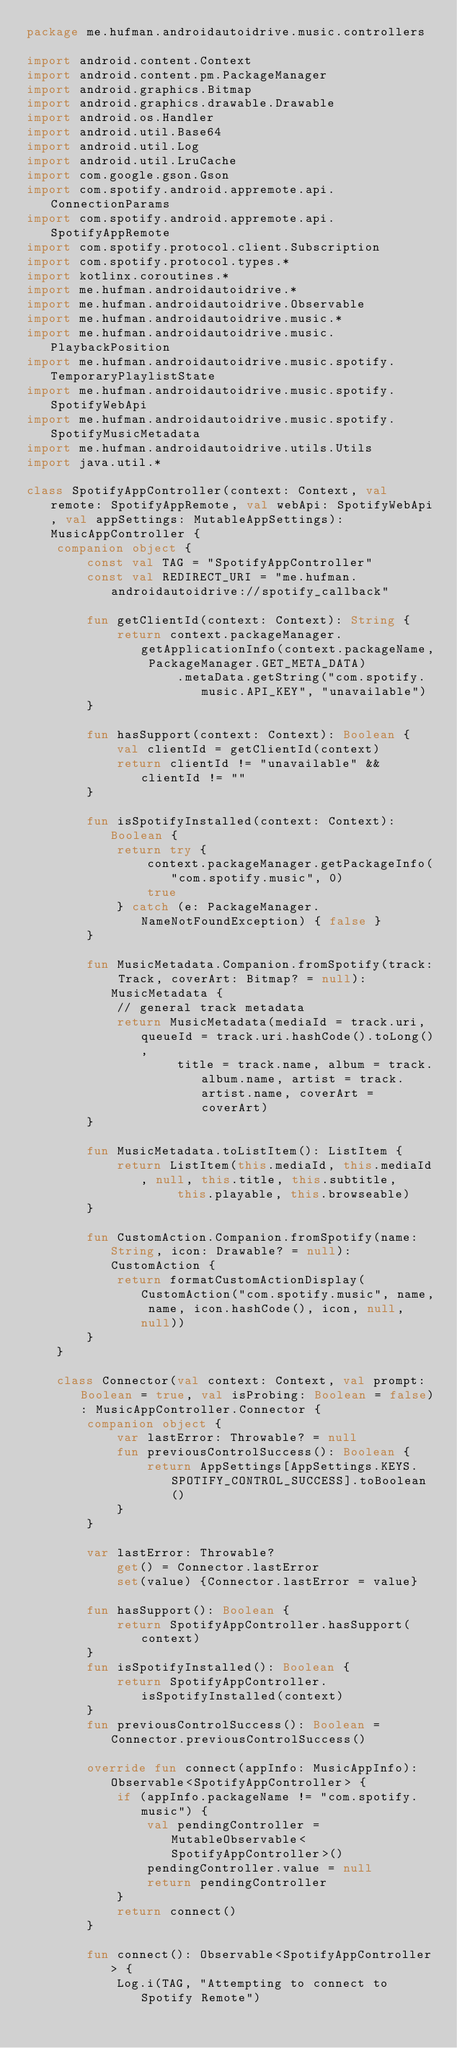Convert code to text. <code><loc_0><loc_0><loc_500><loc_500><_Kotlin_>package me.hufman.androidautoidrive.music.controllers

import android.content.Context
import android.content.pm.PackageManager
import android.graphics.Bitmap
import android.graphics.drawable.Drawable
import android.os.Handler
import android.util.Base64
import android.util.Log
import android.util.LruCache
import com.google.gson.Gson
import com.spotify.android.appremote.api.ConnectionParams
import com.spotify.android.appremote.api.SpotifyAppRemote
import com.spotify.protocol.client.Subscription
import com.spotify.protocol.types.*
import kotlinx.coroutines.*
import me.hufman.androidautoidrive.*
import me.hufman.androidautoidrive.Observable
import me.hufman.androidautoidrive.music.*
import me.hufman.androidautoidrive.music.PlaybackPosition
import me.hufman.androidautoidrive.music.spotify.TemporaryPlaylistState
import me.hufman.androidautoidrive.music.spotify.SpotifyWebApi
import me.hufman.androidautoidrive.music.spotify.SpotifyMusicMetadata
import me.hufman.androidautoidrive.utils.Utils
import java.util.*

class SpotifyAppController(context: Context, val remote: SpotifyAppRemote, val webApi: SpotifyWebApi, val appSettings: MutableAppSettings): MusicAppController {
	companion object {
		const val TAG = "SpotifyAppController"
		const val REDIRECT_URI = "me.hufman.androidautoidrive://spotify_callback"

		fun getClientId(context: Context): String {
			return context.packageManager.getApplicationInfo(context.packageName, PackageManager.GET_META_DATA)
					.metaData.getString("com.spotify.music.API_KEY", "unavailable")
		}

		fun hasSupport(context: Context): Boolean {
			val clientId = getClientId(context)
			return clientId != "unavailable" && clientId != ""
		}

		fun isSpotifyInstalled(context: Context): Boolean {
			return try {
				context.packageManager.getPackageInfo("com.spotify.music", 0)
				true
			} catch (e: PackageManager.NameNotFoundException) { false }
		}

		fun MusicMetadata.Companion.fromSpotify(track: Track, coverArt: Bitmap? = null): MusicMetadata {
			// general track metadata
			return MusicMetadata(mediaId = track.uri, queueId = track.uri.hashCode().toLong(),
					title = track.name, album = track.album.name, artist = track.artist.name, coverArt = coverArt)
		}

		fun MusicMetadata.toListItem(): ListItem {
			return ListItem(this.mediaId, this.mediaId, null, this.title, this.subtitle,
					this.playable, this.browseable)
		}

		fun CustomAction.Companion.fromSpotify(name: String, icon: Drawable? = null): CustomAction {
			return formatCustomActionDisplay(CustomAction("com.spotify.music", name, name, icon.hashCode(), icon, null, null))
		}
	}

	class Connector(val context: Context, val prompt: Boolean = true, val isProbing: Boolean = false): MusicAppController.Connector {
		companion object {
			var lastError: Throwable? = null
			fun previousControlSuccess(): Boolean {
				return AppSettings[AppSettings.KEYS.SPOTIFY_CONTROL_SUCCESS].toBoolean()
			}
		}

		var lastError: Throwable?
			get() = Connector.lastError
			set(value) {Connector.lastError = value}

		fun hasSupport(): Boolean {
			return SpotifyAppController.hasSupport(context)
		}
		fun isSpotifyInstalled(): Boolean {
			return SpotifyAppController.isSpotifyInstalled(context)
		}
		fun previousControlSuccess(): Boolean = Connector.previousControlSuccess()

		override fun connect(appInfo: MusicAppInfo): Observable<SpotifyAppController> {
			if (appInfo.packageName != "com.spotify.music") {
				val pendingController = MutableObservable<SpotifyAppController>()
				pendingController.value = null
				return pendingController
			}
			return connect()
		}

		fun connect(): Observable<SpotifyAppController> {
			Log.i(TAG, "Attempting to connect to Spotify Remote")</code> 